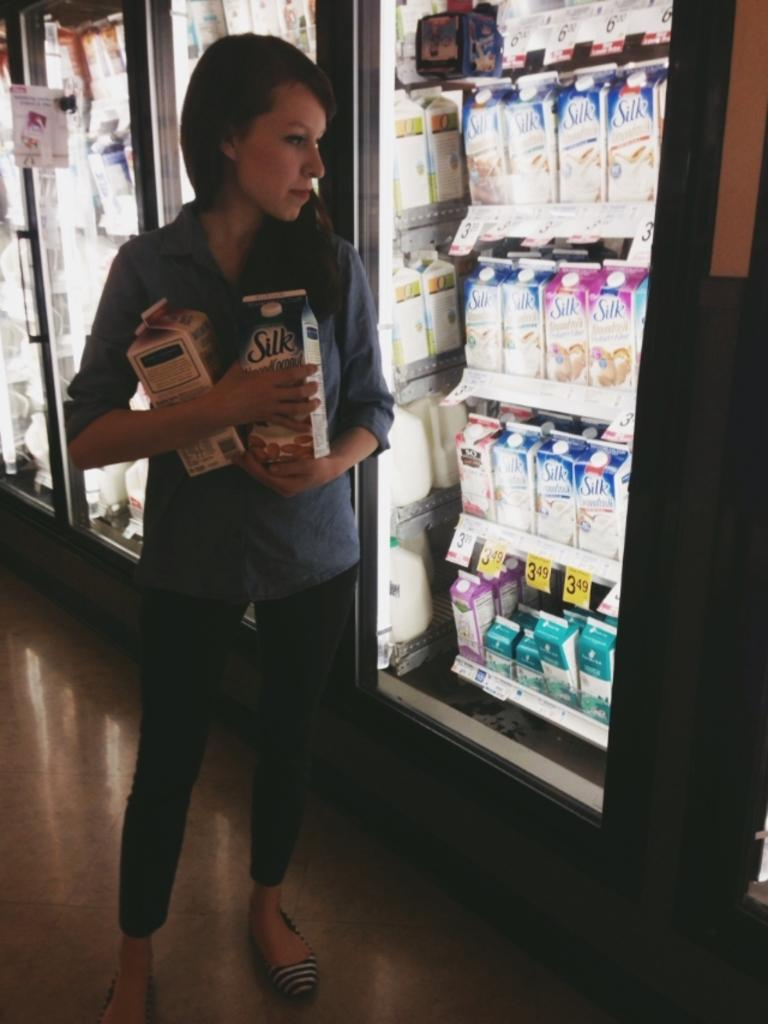<image>
Render a clear and concise summary of the photo. A woman holding two half gallons of Silk milk stands in front of a refrigerated milk display. 